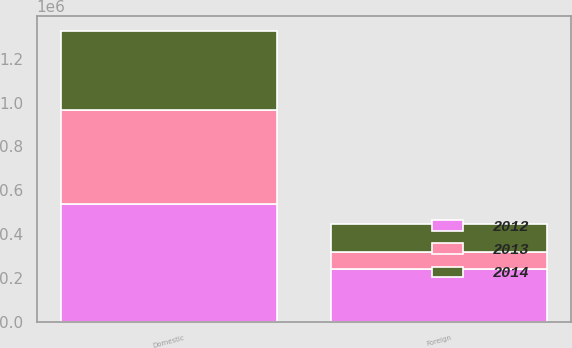Convert chart to OTSL. <chart><loc_0><loc_0><loc_500><loc_500><stacked_bar_chart><ecel><fcel>Domestic<fcel>Foreign<nl><fcel>2012<fcel>537271<fcel>239991<nl><fcel>2013<fcel>431024<fcel>77961<nl><fcel>2014<fcel>361577<fcel>127901<nl></chart> 